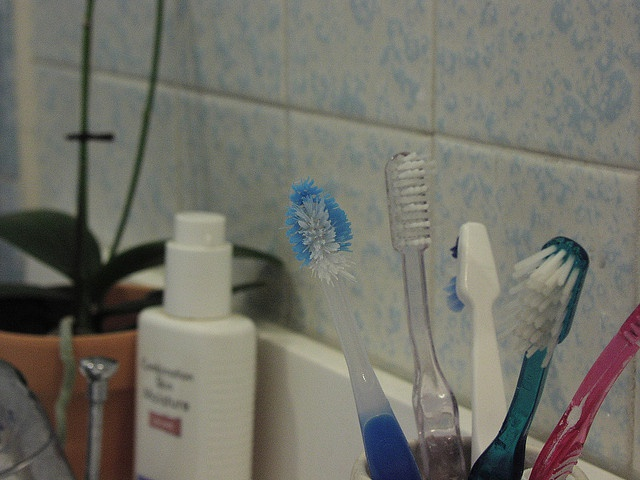Describe the objects in this image and their specific colors. I can see potted plant in gray, black, maroon, and darkgray tones, bottle in gray and darkgray tones, sink in gray, darkgray, and black tones, toothbrush in gray, black, and teal tones, and toothbrush in gray and navy tones in this image. 